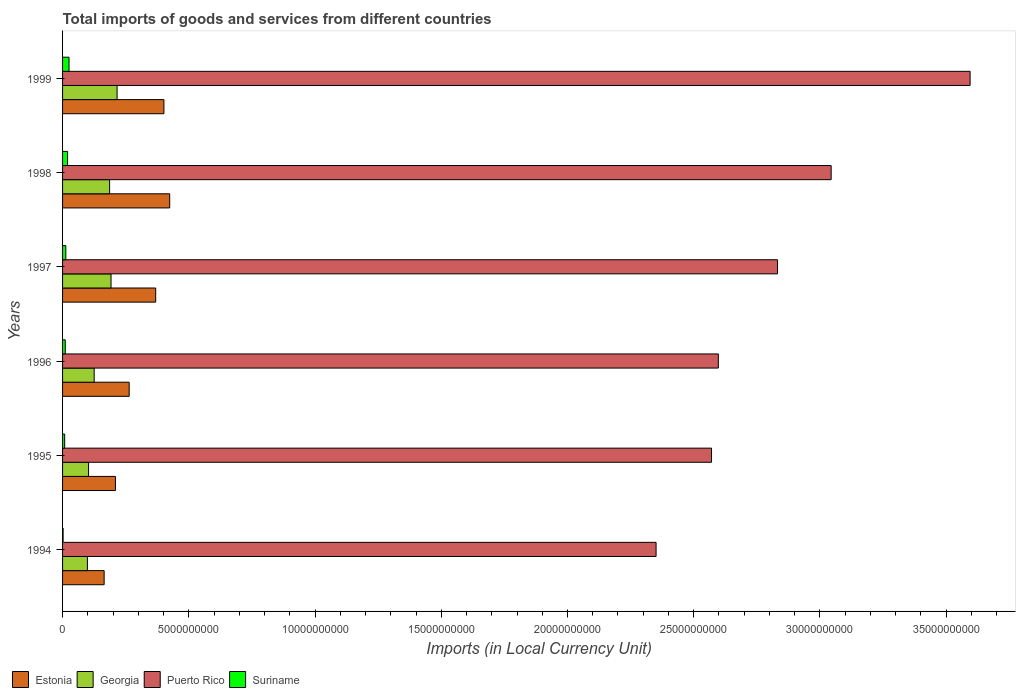Are the number of bars on each tick of the Y-axis equal?
Your answer should be very brief. Yes. How many bars are there on the 4th tick from the top?
Your answer should be very brief. 4. How many bars are there on the 1st tick from the bottom?
Your response must be concise. 4. What is the Amount of goods and services imports in Georgia in 1996?
Your response must be concise. 1.25e+09. Across all years, what is the maximum Amount of goods and services imports in Estonia?
Your answer should be compact. 4.24e+09. Across all years, what is the minimum Amount of goods and services imports in Estonia?
Provide a short and direct response. 1.65e+09. In which year was the Amount of goods and services imports in Puerto Rico maximum?
Provide a short and direct response. 1999. What is the total Amount of goods and services imports in Estonia in the graph?
Provide a short and direct response. 1.83e+1. What is the difference between the Amount of goods and services imports in Suriname in 1994 and that in 1996?
Offer a terse response. -8.47e+07. What is the difference between the Amount of goods and services imports in Georgia in 1995 and the Amount of goods and services imports in Estonia in 1997?
Provide a short and direct response. -2.66e+09. What is the average Amount of goods and services imports in Puerto Rico per year?
Keep it short and to the point. 2.83e+1. In the year 1997, what is the difference between the Amount of goods and services imports in Georgia and Amount of goods and services imports in Puerto Rico?
Your response must be concise. -2.64e+1. In how many years, is the Amount of goods and services imports in Estonia greater than 21000000000 LCU?
Offer a terse response. 0. What is the ratio of the Amount of goods and services imports in Georgia in 1995 to that in 1998?
Give a very brief answer. 0.55. Is the Amount of goods and services imports in Puerto Rico in 1995 less than that in 1996?
Ensure brevity in your answer.  Yes. Is the difference between the Amount of goods and services imports in Georgia in 1994 and 1999 greater than the difference between the Amount of goods and services imports in Puerto Rico in 1994 and 1999?
Your response must be concise. Yes. What is the difference between the highest and the second highest Amount of goods and services imports in Puerto Rico?
Your answer should be compact. 5.50e+09. What is the difference between the highest and the lowest Amount of goods and services imports in Suriname?
Give a very brief answer. 2.35e+08. Is it the case that in every year, the sum of the Amount of goods and services imports in Suriname and Amount of goods and services imports in Estonia is greater than the sum of Amount of goods and services imports in Puerto Rico and Amount of goods and services imports in Georgia?
Your answer should be very brief. No. What does the 4th bar from the top in 1999 represents?
Keep it short and to the point. Estonia. What does the 3rd bar from the bottom in 1997 represents?
Your answer should be compact. Puerto Rico. How many bars are there?
Your response must be concise. 24. Are all the bars in the graph horizontal?
Provide a succinct answer. Yes. Where does the legend appear in the graph?
Provide a succinct answer. Bottom left. What is the title of the graph?
Provide a succinct answer. Total imports of goods and services from different countries. What is the label or title of the X-axis?
Keep it short and to the point. Imports (in Local Currency Unit). What is the label or title of the Y-axis?
Keep it short and to the point. Years. What is the Imports (in Local Currency Unit) in Estonia in 1994?
Offer a very short reply. 1.65e+09. What is the Imports (in Local Currency Unit) of Georgia in 1994?
Your answer should be compact. 9.85e+08. What is the Imports (in Local Currency Unit) in Puerto Rico in 1994?
Offer a terse response. 2.35e+1. What is the Imports (in Local Currency Unit) in Suriname in 1994?
Your answer should be very brief. 2.14e+07. What is the Imports (in Local Currency Unit) in Estonia in 1995?
Your response must be concise. 2.09e+09. What is the Imports (in Local Currency Unit) in Georgia in 1995?
Give a very brief answer. 1.03e+09. What is the Imports (in Local Currency Unit) of Puerto Rico in 1995?
Give a very brief answer. 2.57e+1. What is the Imports (in Local Currency Unit) in Suriname in 1995?
Offer a very short reply. 8.35e+07. What is the Imports (in Local Currency Unit) in Estonia in 1996?
Offer a terse response. 2.64e+09. What is the Imports (in Local Currency Unit) of Georgia in 1996?
Provide a succinct answer. 1.25e+09. What is the Imports (in Local Currency Unit) of Puerto Rico in 1996?
Offer a very short reply. 2.60e+1. What is the Imports (in Local Currency Unit) of Suriname in 1996?
Ensure brevity in your answer.  1.06e+08. What is the Imports (in Local Currency Unit) of Estonia in 1997?
Make the answer very short. 3.69e+09. What is the Imports (in Local Currency Unit) in Georgia in 1997?
Your answer should be very brief. 1.92e+09. What is the Imports (in Local Currency Unit) in Puerto Rico in 1997?
Keep it short and to the point. 2.83e+1. What is the Imports (in Local Currency Unit) in Suriname in 1997?
Provide a succinct answer. 1.29e+08. What is the Imports (in Local Currency Unit) in Estonia in 1998?
Ensure brevity in your answer.  4.24e+09. What is the Imports (in Local Currency Unit) in Georgia in 1998?
Your answer should be compact. 1.86e+09. What is the Imports (in Local Currency Unit) of Puerto Rico in 1998?
Make the answer very short. 3.04e+1. What is the Imports (in Local Currency Unit) in Suriname in 1998?
Make the answer very short. 1.98e+08. What is the Imports (in Local Currency Unit) of Estonia in 1999?
Ensure brevity in your answer.  4.01e+09. What is the Imports (in Local Currency Unit) of Georgia in 1999?
Provide a short and direct response. 2.16e+09. What is the Imports (in Local Currency Unit) in Puerto Rico in 1999?
Give a very brief answer. 3.59e+1. What is the Imports (in Local Currency Unit) of Suriname in 1999?
Provide a short and direct response. 2.56e+08. Across all years, what is the maximum Imports (in Local Currency Unit) in Estonia?
Give a very brief answer. 4.24e+09. Across all years, what is the maximum Imports (in Local Currency Unit) of Georgia?
Your response must be concise. 2.16e+09. Across all years, what is the maximum Imports (in Local Currency Unit) in Puerto Rico?
Your answer should be very brief. 3.59e+1. Across all years, what is the maximum Imports (in Local Currency Unit) of Suriname?
Keep it short and to the point. 2.56e+08. Across all years, what is the minimum Imports (in Local Currency Unit) in Estonia?
Your response must be concise. 1.65e+09. Across all years, what is the minimum Imports (in Local Currency Unit) in Georgia?
Offer a very short reply. 9.85e+08. Across all years, what is the minimum Imports (in Local Currency Unit) of Puerto Rico?
Provide a short and direct response. 2.35e+1. Across all years, what is the minimum Imports (in Local Currency Unit) of Suriname?
Your answer should be compact. 2.14e+07. What is the total Imports (in Local Currency Unit) of Estonia in the graph?
Keep it short and to the point. 1.83e+1. What is the total Imports (in Local Currency Unit) of Georgia in the graph?
Give a very brief answer. 9.21e+09. What is the total Imports (in Local Currency Unit) in Puerto Rico in the graph?
Offer a terse response. 1.70e+11. What is the total Imports (in Local Currency Unit) of Suriname in the graph?
Offer a terse response. 7.95e+08. What is the difference between the Imports (in Local Currency Unit) of Estonia in 1994 and that in 1995?
Make the answer very short. -4.48e+08. What is the difference between the Imports (in Local Currency Unit) in Georgia in 1994 and that in 1995?
Offer a terse response. -4.48e+07. What is the difference between the Imports (in Local Currency Unit) of Puerto Rico in 1994 and that in 1995?
Offer a very short reply. -2.20e+09. What is the difference between the Imports (in Local Currency Unit) in Suriname in 1994 and that in 1995?
Your answer should be very brief. -6.20e+07. What is the difference between the Imports (in Local Currency Unit) of Estonia in 1994 and that in 1996?
Provide a short and direct response. -9.92e+08. What is the difference between the Imports (in Local Currency Unit) in Georgia in 1994 and that in 1996?
Your answer should be compact. -2.68e+08. What is the difference between the Imports (in Local Currency Unit) in Puerto Rico in 1994 and that in 1996?
Your response must be concise. -2.47e+09. What is the difference between the Imports (in Local Currency Unit) in Suriname in 1994 and that in 1996?
Give a very brief answer. -8.47e+07. What is the difference between the Imports (in Local Currency Unit) of Estonia in 1994 and that in 1997?
Your answer should be compact. -2.04e+09. What is the difference between the Imports (in Local Currency Unit) in Georgia in 1994 and that in 1997?
Provide a short and direct response. -9.35e+08. What is the difference between the Imports (in Local Currency Unit) in Puerto Rico in 1994 and that in 1997?
Your answer should be very brief. -4.81e+09. What is the difference between the Imports (in Local Currency Unit) of Suriname in 1994 and that in 1997?
Your answer should be compact. -1.08e+08. What is the difference between the Imports (in Local Currency Unit) of Estonia in 1994 and that in 1998?
Give a very brief answer. -2.60e+09. What is the difference between the Imports (in Local Currency Unit) of Georgia in 1994 and that in 1998?
Give a very brief answer. -8.79e+08. What is the difference between the Imports (in Local Currency Unit) in Puerto Rico in 1994 and that in 1998?
Ensure brevity in your answer.  -6.94e+09. What is the difference between the Imports (in Local Currency Unit) in Suriname in 1994 and that in 1998?
Give a very brief answer. -1.77e+08. What is the difference between the Imports (in Local Currency Unit) of Estonia in 1994 and that in 1999?
Your answer should be compact. -2.37e+09. What is the difference between the Imports (in Local Currency Unit) in Georgia in 1994 and that in 1999?
Provide a short and direct response. -1.17e+09. What is the difference between the Imports (in Local Currency Unit) of Puerto Rico in 1994 and that in 1999?
Ensure brevity in your answer.  -1.24e+1. What is the difference between the Imports (in Local Currency Unit) of Suriname in 1994 and that in 1999?
Offer a very short reply. -2.35e+08. What is the difference between the Imports (in Local Currency Unit) in Estonia in 1995 and that in 1996?
Provide a short and direct response. -5.44e+08. What is the difference between the Imports (in Local Currency Unit) of Georgia in 1995 and that in 1996?
Your answer should be compact. -2.23e+08. What is the difference between the Imports (in Local Currency Unit) in Puerto Rico in 1995 and that in 1996?
Offer a terse response. -2.71e+08. What is the difference between the Imports (in Local Currency Unit) of Suriname in 1995 and that in 1996?
Make the answer very short. -2.27e+07. What is the difference between the Imports (in Local Currency Unit) in Estonia in 1995 and that in 1997?
Provide a succinct answer. -1.59e+09. What is the difference between the Imports (in Local Currency Unit) in Georgia in 1995 and that in 1997?
Give a very brief answer. -8.90e+08. What is the difference between the Imports (in Local Currency Unit) in Puerto Rico in 1995 and that in 1997?
Your answer should be very brief. -2.62e+09. What is the difference between the Imports (in Local Currency Unit) of Suriname in 1995 and that in 1997?
Provide a short and direct response. -4.59e+07. What is the difference between the Imports (in Local Currency Unit) in Estonia in 1995 and that in 1998?
Keep it short and to the point. -2.15e+09. What is the difference between the Imports (in Local Currency Unit) in Georgia in 1995 and that in 1998?
Provide a succinct answer. -8.34e+08. What is the difference between the Imports (in Local Currency Unit) of Puerto Rico in 1995 and that in 1998?
Give a very brief answer. -4.74e+09. What is the difference between the Imports (in Local Currency Unit) in Suriname in 1995 and that in 1998?
Your response must be concise. -1.15e+08. What is the difference between the Imports (in Local Currency Unit) in Estonia in 1995 and that in 1999?
Make the answer very short. -1.92e+09. What is the difference between the Imports (in Local Currency Unit) of Georgia in 1995 and that in 1999?
Provide a short and direct response. -1.13e+09. What is the difference between the Imports (in Local Currency Unit) of Puerto Rico in 1995 and that in 1999?
Provide a succinct answer. -1.02e+1. What is the difference between the Imports (in Local Currency Unit) in Suriname in 1995 and that in 1999?
Provide a short and direct response. -1.73e+08. What is the difference between the Imports (in Local Currency Unit) in Estonia in 1996 and that in 1997?
Offer a very short reply. -1.05e+09. What is the difference between the Imports (in Local Currency Unit) of Georgia in 1996 and that in 1997?
Provide a succinct answer. -6.67e+08. What is the difference between the Imports (in Local Currency Unit) in Puerto Rico in 1996 and that in 1997?
Ensure brevity in your answer.  -2.34e+09. What is the difference between the Imports (in Local Currency Unit) of Suriname in 1996 and that in 1997?
Make the answer very short. -2.32e+07. What is the difference between the Imports (in Local Currency Unit) in Estonia in 1996 and that in 1998?
Provide a succinct answer. -1.61e+09. What is the difference between the Imports (in Local Currency Unit) in Georgia in 1996 and that in 1998?
Your answer should be very brief. -6.11e+08. What is the difference between the Imports (in Local Currency Unit) in Puerto Rico in 1996 and that in 1998?
Make the answer very short. -4.47e+09. What is the difference between the Imports (in Local Currency Unit) in Suriname in 1996 and that in 1998?
Give a very brief answer. -9.22e+07. What is the difference between the Imports (in Local Currency Unit) in Estonia in 1996 and that in 1999?
Offer a terse response. -1.38e+09. What is the difference between the Imports (in Local Currency Unit) of Georgia in 1996 and that in 1999?
Provide a succinct answer. -9.07e+08. What is the difference between the Imports (in Local Currency Unit) of Puerto Rico in 1996 and that in 1999?
Offer a very short reply. -9.97e+09. What is the difference between the Imports (in Local Currency Unit) of Suriname in 1996 and that in 1999?
Make the answer very short. -1.50e+08. What is the difference between the Imports (in Local Currency Unit) in Estonia in 1997 and that in 1998?
Your response must be concise. -5.55e+08. What is the difference between the Imports (in Local Currency Unit) in Georgia in 1997 and that in 1998?
Provide a succinct answer. 5.60e+07. What is the difference between the Imports (in Local Currency Unit) in Puerto Rico in 1997 and that in 1998?
Your answer should be very brief. -2.12e+09. What is the difference between the Imports (in Local Currency Unit) of Suriname in 1997 and that in 1998?
Offer a terse response. -6.90e+07. What is the difference between the Imports (in Local Currency Unit) of Estonia in 1997 and that in 1999?
Provide a succinct answer. -3.26e+08. What is the difference between the Imports (in Local Currency Unit) in Georgia in 1997 and that in 1999?
Give a very brief answer. -2.40e+08. What is the difference between the Imports (in Local Currency Unit) in Puerto Rico in 1997 and that in 1999?
Provide a succinct answer. -7.63e+09. What is the difference between the Imports (in Local Currency Unit) of Suriname in 1997 and that in 1999?
Offer a very short reply. -1.27e+08. What is the difference between the Imports (in Local Currency Unit) of Estonia in 1998 and that in 1999?
Keep it short and to the point. 2.29e+08. What is the difference between the Imports (in Local Currency Unit) of Georgia in 1998 and that in 1999?
Provide a short and direct response. -2.96e+08. What is the difference between the Imports (in Local Currency Unit) of Puerto Rico in 1998 and that in 1999?
Offer a terse response. -5.50e+09. What is the difference between the Imports (in Local Currency Unit) of Suriname in 1998 and that in 1999?
Ensure brevity in your answer.  -5.77e+07. What is the difference between the Imports (in Local Currency Unit) in Estonia in 1994 and the Imports (in Local Currency Unit) in Georgia in 1995?
Your answer should be compact. 6.17e+08. What is the difference between the Imports (in Local Currency Unit) of Estonia in 1994 and the Imports (in Local Currency Unit) of Puerto Rico in 1995?
Make the answer very short. -2.41e+1. What is the difference between the Imports (in Local Currency Unit) in Estonia in 1994 and the Imports (in Local Currency Unit) in Suriname in 1995?
Give a very brief answer. 1.56e+09. What is the difference between the Imports (in Local Currency Unit) of Georgia in 1994 and the Imports (in Local Currency Unit) of Puerto Rico in 1995?
Provide a short and direct response. -2.47e+1. What is the difference between the Imports (in Local Currency Unit) in Georgia in 1994 and the Imports (in Local Currency Unit) in Suriname in 1995?
Keep it short and to the point. 9.01e+08. What is the difference between the Imports (in Local Currency Unit) of Puerto Rico in 1994 and the Imports (in Local Currency Unit) of Suriname in 1995?
Provide a succinct answer. 2.34e+1. What is the difference between the Imports (in Local Currency Unit) in Estonia in 1994 and the Imports (in Local Currency Unit) in Georgia in 1996?
Provide a short and direct response. 3.95e+08. What is the difference between the Imports (in Local Currency Unit) of Estonia in 1994 and the Imports (in Local Currency Unit) of Puerto Rico in 1996?
Offer a very short reply. -2.43e+1. What is the difference between the Imports (in Local Currency Unit) in Estonia in 1994 and the Imports (in Local Currency Unit) in Suriname in 1996?
Provide a short and direct response. 1.54e+09. What is the difference between the Imports (in Local Currency Unit) of Georgia in 1994 and the Imports (in Local Currency Unit) of Puerto Rico in 1996?
Make the answer very short. -2.50e+1. What is the difference between the Imports (in Local Currency Unit) in Georgia in 1994 and the Imports (in Local Currency Unit) in Suriname in 1996?
Offer a very short reply. 8.79e+08. What is the difference between the Imports (in Local Currency Unit) in Puerto Rico in 1994 and the Imports (in Local Currency Unit) in Suriname in 1996?
Ensure brevity in your answer.  2.34e+1. What is the difference between the Imports (in Local Currency Unit) of Estonia in 1994 and the Imports (in Local Currency Unit) of Georgia in 1997?
Provide a succinct answer. -2.73e+08. What is the difference between the Imports (in Local Currency Unit) of Estonia in 1994 and the Imports (in Local Currency Unit) of Puerto Rico in 1997?
Your response must be concise. -2.67e+1. What is the difference between the Imports (in Local Currency Unit) of Estonia in 1994 and the Imports (in Local Currency Unit) of Suriname in 1997?
Your answer should be very brief. 1.52e+09. What is the difference between the Imports (in Local Currency Unit) of Georgia in 1994 and the Imports (in Local Currency Unit) of Puerto Rico in 1997?
Offer a very short reply. -2.73e+1. What is the difference between the Imports (in Local Currency Unit) in Georgia in 1994 and the Imports (in Local Currency Unit) in Suriname in 1997?
Offer a very short reply. 8.55e+08. What is the difference between the Imports (in Local Currency Unit) in Puerto Rico in 1994 and the Imports (in Local Currency Unit) in Suriname in 1997?
Your answer should be compact. 2.34e+1. What is the difference between the Imports (in Local Currency Unit) in Estonia in 1994 and the Imports (in Local Currency Unit) in Georgia in 1998?
Your answer should be very brief. -2.17e+08. What is the difference between the Imports (in Local Currency Unit) of Estonia in 1994 and the Imports (in Local Currency Unit) of Puerto Rico in 1998?
Keep it short and to the point. -2.88e+1. What is the difference between the Imports (in Local Currency Unit) of Estonia in 1994 and the Imports (in Local Currency Unit) of Suriname in 1998?
Your response must be concise. 1.45e+09. What is the difference between the Imports (in Local Currency Unit) of Georgia in 1994 and the Imports (in Local Currency Unit) of Puerto Rico in 1998?
Make the answer very short. -2.95e+1. What is the difference between the Imports (in Local Currency Unit) in Georgia in 1994 and the Imports (in Local Currency Unit) in Suriname in 1998?
Ensure brevity in your answer.  7.86e+08. What is the difference between the Imports (in Local Currency Unit) in Puerto Rico in 1994 and the Imports (in Local Currency Unit) in Suriname in 1998?
Keep it short and to the point. 2.33e+1. What is the difference between the Imports (in Local Currency Unit) in Estonia in 1994 and the Imports (in Local Currency Unit) in Georgia in 1999?
Offer a terse response. -5.13e+08. What is the difference between the Imports (in Local Currency Unit) in Estonia in 1994 and the Imports (in Local Currency Unit) in Puerto Rico in 1999?
Keep it short and to the point. -3.43e+1. What is the difference between the Imports (in Local Currency Unit) of Estonia in 1994 and the Imports (in Local Currency Unit) of Suriname in 1999?
Your answer should be compact. 1.39e+09. What is the difference between the Imports (in Local Currency Unit) of Georgia in 1994 and the Imports (in Local Currency Unit) of Puerto Rico in 1999?
Your response must be concise. -3.50e+1. What is the difference between the Imports (in Local Currency Unit) in Georgia in 1994 and the Imports (in Local Currency Unit) in Suriname in 1999?
Provide a short and direct response. 7.29e+08. What is the difference between the Imports (in Local Currency Unit) in Puerto Rico in 1994 and the Imports (in Local Currency Unit) in Suriname in 1999?
Your response must be concise. 2.33e+1. What is the difference between the Imports (in Local Currency Unit) of Estonia in 1995 and the Imports (in Local Currency Unit) of Georgia in 1996?
Offer a terse response. 8.42e+08. What is the difference between the Imports (in Local Currency Unit) of Estonia in 1995 and the Imports (in Local Currency Unit) of Puerto Rico in 1996?
Provide a short and direct response. -2.39e+1. What is the difference between the Imports (in Local Currency Unit) of Estonia in 1995 and the Imports (in Local Currency Unit) of Suriname in 1996?
Provide a short and direct response. 1.99e+09. What is the difference between the Imports (in Local Currency Unit) in Georgia in 1995 and the Imports (in Local Currency Unit) in Puerto Rico in 1996?
Offer a terse response. -2.49e+1. What is the difference between the Imports (in Local Currency Unit) of Georgia in 1995 and the Imports (in Local Currency Unit) of Suriname in 1996?
Your answer should be compact. 9.23e+08. What is the difference between the Imports (in Local Currency Unit) in Puerto Rico in 1995 and the Imports (in Local Currency Unit) in Suriname in 1996?
Ensure brevity in your answer.  2.56e+1. What is the difference between the Imports (in Local Currency Unit) of Estonia in 1995 and the Imports (in Local Currency Unit) of Georgia in 1997?
Offer a terse response. 1.75e+08. What is the difference between the Imports (in Local Currency Unit) of Estonia in 1995 and the Imports (in Local Currency Unit) of Puerto Rico in 1997?
Ensure brevity in your answer.  -2.62e+1. What is the difference between the Imports (in Local Currency Unit) of Estonia in 1995 and the Imports (in Local Currency Unit) of Suriname in 1997?
Your answer should be very brief. 1.96e+09. What is the difference between the Imports (in Local Currency Unit) of Georgia in 1995 and the Imports (in Local Currency Unit) of Puerto Rico in 1997?
Provide a short and direct response. -2.73e+1. What is the difference between the Imports (in Local Currency Unit) of Georgia in 1995 and the Imports (in Local Currency Unit) of Suriname in 1997?
Provide a succinct answer. 9.00e+08. What is the difference between the Imports (in Local Currency Unit) in Puerto Rico in 1995 and the Imports (in Local Currency Unit) in Suriname in 1997?
Keep it short and to the point. 2.56e+1. What is the difference between the Imports (in Local Currency Unit) of Estonia in 1995 and the Imports (in Local Currency Unit) of Georgia in 1998?
Provide a short and direct response. 2.31e+08. What is the difference between the Imports (in Local Currency Unit) in Estonia in 1995 and the Imports (in Local Currency Unit) in Puerto Rico in 1998?
Provide a short and direct response. -2.83e+1. What is the difference between the Imports (in Local Currency Unit) of Estonia in 1995 and the Imports (in Local Currency Unit) of Suriname in 1998?
Your answer should be very brief. 1.90e+09. What is the difference between the Imports (in Local Currency Unit) of Georgia in 1995 and the Imports (in Local Currency Unit) of Puerto Rico in 1998?
Ensure brevity in your answer.  -2.94e+1. What is the difference between the Imports (in Local Currency Unit) in Georgia in 1995 and the Imports (in Local Currency Unit) in Suriname in 1998?
Ensure brevity in your answer.  8.31e+08. What is the difference between the Imports (in Local Currency Unit) of Puerto Rico in 1995 and the Imports (in Local Currency Unit) of Suriname in 1998?
Give a very brief answer. 2.55e+1. What is the difference between the Imports (in Local Currency Unit) of Estonia in 1995 and the Imports (in Local Currency Unit) of Georgia in 1999?
Your response must be concise. -6.52e+07. What is the difference between the Imports (in Local Currency Unit) of Estonia in 1995 and the Imports (in Local Currency Unit) of Puerto Rico in 1999?
Give a very brief answer. -3.39e+1. What is the difference between the Imports (in Local Currency Unit) of Estonia in 1995 and the Imports (in Local Currency Unit) of Suriname in 1999?
Make the answer very short. 1.84e+09. What is the difference between the Imports (in Local Currency Unit) of Georgia in 1995 and the Imports (in Local Currency Unit) of Puerto Rico in 1999?
Provide a succinct answer. -3.49e+1. What is the difference between the Imports (in Local Currency Unit) in Georgia in 1995 and the Imports (in Local Currency Unit) in Suriname in 1999?
Ensure brevity in your answer.  7.73e+08. What is the difference between the Imports (in Local Currency Unit) in Puerto Rico in 1995 and the Imports (in Local Currency Unit) in Suriname in 1999?
Keep it short and to the point. 2.54e+1. What is the difference between the Imports (in Local Currency Unit) in Estonia in 1996 and the Imports (in Local Currency Unit) in Georgia in 1997?
Your answer should be compact. 7.19e+08. What is the difference between the Imports (in Local Currency Unit) in Estonia in 1996 and the Imports (in Local Currency Unit) in Puerto Rico in 1997?
Make the answer very short. -2.57e+1. What is the difference between the Imports (in Local Currency Unit) in Estonia in 1996 and the Imports (in Local Currency Unit) in Suriname in 1997?
Provide a short and direct response. 2.51e+09. What is the difference between the Imports (in Local Currency Unit) of Georgia in 1996 and the Imports (in Local Currency Unit) of Puerto Rico in 1997?
Make the answer very short. -2.71e+1. What is the difference between the Imports (in Local Currency Unit) of Georgia in 1996 and the Imports (in Local Currency Unit) of Suriname in 1997?
Your answer should be compact. 1.12e+09. What is the difference between the Imports (in Local Currency Unit) in Puerto Rico in 1996 and the Imports (in Local Currency Unit) in Suriname in 1997?
Provide a short and direct response. 2.58e+1. What is the difference between the Imports (in Local Currency Unit) of Estonia in 1996 and the Imports (in Local Currency Unit) of Georgia in 1998?
Ensure brevity in your answer.  7.75e+08. What is the difference between the Imports (in Local Currency Unit) in Estonia in 1996 and the Imports (in Local Currency Unit) in Puerto Rico in 1998?
Give a very brief answer. -2.78e+1. What is the difference between the Imports (in Local Currency Unit) of Estonia in 1996 and the Imports (in Local Currency Unit) of Suriname in 1998?
Offer a very short reply. 2.44e+09. What is the difference between the Imports (in Local Currency Unit) in Georgia in 1996 and the Imports (in Local Currency Unit) in Puerto Rico in 1998?
Provide a succinct answer. -2.92e+1. What is the difference between the Imports (in Local Currency Unit) in Georgia in 1996 and the Imports (in Local Currency Unit) in Suriname in 1998?
Offer a very short reply. 1.05e+09. What is the difference between the Imports (in Local Currency Unit) of Puerto Rico in 1996 and the Imports (in Local Currency Unit) of Suriname in 1998?
Give a very brief answer. 2.58e+1. What is the difference between the Imports (in Local Currency Unit) of Estonia in 1996 and the Imports (in Local Currency Unit) of Georgia in 1999?
Make the answer very short. 4.79e+08. What is the difference between the Imports (in Local Currency Unit) of Estonia in 1996 and the Imports (in Local Currency Unit) of Puerto Rico in 1999?
Offer a terse response. -3.33e+1. What is the difference between the Imports (in Local Currency Unit) in Estonia in 1996 and the Imports (in Local Currency Unit) in Suriname in 1999?
Make the answer very short. 2.38e+09. What is the difference between the Imports (in Local Currency Unit) of Georgia in 1996 and the Imports (in Local Currency Unit) of Puerto Rico in 1999?
Ensure brevity in your answer.  -3.47e+1. What is the difference between the Imports (in Local Currency Unit) of Georgia in 1996 and the Imports (in Local Currency Unit) of Suriname in 1999?
Provide a succinct answer. 9.96e+08. What is the difference between the Imports (in Local Currency Unit) in Puerto Rico in 1996 and the Imports (in Local Currency Unit) in Suriname in 1999?
Your answer should be compact. 2.57e+1. What is the difference between the Imports (in Local Currency Unit) of Estonia in 1997 and the Imports (in Local Currency Unit) of Georgia in 1998?
Keep it short and to the point. 1.83e+09. What is the difference between the Imports (in Local Currency Unit) of Estonia in 1997 and the Imports (in Local Currency Unit) of Puerto Rico in 1998?
Offer a very short reply. -2.68e+1. What is the difference between the Imports (in Local Currency Unit) in Estonia in 1997 and the Imports (in Local Currency Unit) in Suriname in 1998?
Provide a succinct answer. 3.49e+09. What is the difference between the Imports (in Local Currency Unit) in Georgia in 1997 and the Imports (in Local Currency Unit) in Puerto Rico in 1998?
Your answer should be very brief. -2.85e+1. What is the difference between the Imports (in Local Currency Unit) in Georgia in 1997 and the Imports (in Local Currency Unit) in Suriname in 1998?
Provide a short and direct response. 1.72e+09. What is the difference between the Imports (in Local Currency Unit) of Puerto Rico in 1997 and the Imports (in Local Currency Unit) of Suriname in 1998?
Ensure brevity in your answer.  2.81e+1. What is the difference between the Imports (in Local Currency Unit) of Estonia in 1997 and the Imports (in Local Currency Unit) of Georgia in 1999?
Keep it short and to the point. 1.53e+09. What is the difference between the Imports (in Local Currency Unit) of Estonia in 1997 and the Imports (in Local Currency Unit) of Puerto Rico in 1999?
Provide a succinct answer. -3.23e+1. What is the difference between the Imports (in Local Currency Unit) in Estonia in 1997 and the Imports (in Local Currency Unit) in Suriname in 1999?
Offer a very short reply. 3.43e+09. What is the difference between the Imports (in Local Currency Unit) of Georgia in 1997 and the Imports (in Local Currency Unit) of Puerto Rico in 1999?
Your response must be concise. -3.40e+1. What is the difference between the Imports (in Local Currency Unit) of Georgia in 1997 and the Imports (in Local Currency Unit) of Suriname in 1999?
Your answer should be compact. 1.66e+09. What is the difference between the Imports (in Local Currency Unit) in Puerto Rico in 1997 and the Imports (in Local Currency Unit) in Suriname in 1999?
Keep it short and to the point. 2.81e+1. What is the difference between the Imports (in Local Currency Unit) of Estonia in 1998 and the Imports (in Local Currency Unit) of Georgia in 1999?
Keep it short and to the point. 2.08e+09. What is the difference between the Imports (in Local Currency Unit) in Estonia in 1998 and the Imports (in Local Currency Unit) in Puerto Rico in 1999?
Provide a succinct answer. -3.17e+1. What is the difference between the Imports (in Local Currency Unit) of Estonia in 1998 and the Imports (in Local Currency Unit) of Suriname in 1999?
Your answer should be very brief. 3.99e+09. What is the difference between the Imports (in Local Currency Unit) of Georgia in 1998 and the Imports (in Local Currency Unit) of Puerto Rico in 1999?
Keep it short and to the point. -3.41e+1. What is the difference between the Imports (in Local Currency Unit) of Georgia in 1998 and the Imports (in Local Currency Unit) of Suriname in 1999?
Keep it short and to the point. 1.61e+09. What is the difference between the Imports (in Local Currency Unit) in Puerto Rico in 1998 and the Imports (in Local Currency Unit) in Suriname in 1999?
Offer a terse response. 3.02e+1. What is the average Imports (in Local Currency Unit) of Estonia per year?
Your answer should be very brief. 3.05e+09. What is the average Imports (in Local Currency Unit) in Georgia per year?
Your answer should be very brief. 1.53e+09. What is the average Imports (in Local Currency Unit) in Puerto Rico per year?
Ensure brevity in your answer.  2.83e+1. What is the average Imports (in Local Currency Unit) in Suriname per year?
Keep it short and to the point. 1.32e+08. In the year 1994, what is the difference between the Imports (in Local Currency Unit) of Estonia and Imports (in Local Currency Unit) of Georgia?
Your answer should be compact. 6.62e+08. In the year 1994, what is the difference between the Imports (in Local Currency Unit) of Estonia and Imports (in Local Currency Unit) of Puerto Rico?
Provide a succinct answer. -2.19e+1. In the year 1994, what is the difference between the Imports (in Local Currency Unit) of Estonia and Imports (in Local Currency Unit) of Suriname?
Give a very brief answer. 1.63e+09. In the year 1994, what is the difference between the Imports (in Local Currency Unit) in Georgia and Imports (in Local Currency Unit) in Puerto Rico?
Provide a short and direct response. -2.25e+1. In the year 1994, what is the difference between the Imports (in Local Currency Unit) of Georgia and Imports (in Local Currency Unit) of Suriname?
Offer a very short reply. 9.63e+08. In the year 1994, what is the difference between the Imports (in Local Currency Unit) in Puerto Rico and Imports (in Local Currency Unit) in Suriname?
Provide a succinct answer. 2.35e+1. In the year 1995, what is the difference between the Imports (in Local Currency Unit) in Estonia and Imports (in Local Currency Unit) in Georgia?
Keep it short and to the point. 1.06e+09. In the year 1995, what is the difference between the Imports (in Local Currency Unit) of Estonia and Imports (in Local Currency Unit) of Puerto Rico?
Offer a terse response. -2.36e+1. In the year 1995, what is the difference between the Imports (in Local Currency Unit) of Estonia and Imports (in Local Currency Unit) of Suriname?
Your response must be concise. 2.01e+09. In the year 1995, what is the difference between the Imports (in Local Currency Unit) of Georgia and Imports (in Local Currency Unit) of Puerto Rico?
Provide a short and direct response. -2.47e+1. In the year 1995, what is the difference between the Imports (in Local Currency Unit) in Georgia and Imports (in Local Currency Unit) in Suriname?
Give a very brief answer. 9.46e+08. In the year 1995, what is the difference between the Imports (in Local Currency Unit) of Puerto Rico and Imports (in Local Currency Unit) of Suriname?
Provide a short and direct response. 2.56e+1. In the year 1996, what is the difference between the Imports (in Local Currency Unit) of Estonia and Imports (in Local Currency Unit) of Georgia?
Your response must be concise. 1.39e+09. In the year 1996, what is the difference between the Imports (in Local Currency Unit) of Estonia and Imports (in Local Currency Unit) of Puerto Rico?
Your response must be concise. -2.33e+1. In the year 1996, what is the difference between the Imports (in Local Currency Unit) in Estonia and Imports (in Local Currency Unit) in Suriname?
Offer a terse response. 2.53e+09. In the year 1996, what is the difference between the Imports (in Local Currency Unit) in Georgia and Imports (in Local Currency Unit) in Puerto Rico?
Provide a short and direct response. -2.47e+1. In the year 1996, what is the difference between the Imports (in Local Currency Unit) in Georgia and Imports (in Local Currency Unit) in Suriname?
Make the answer very short. 1.15e+09. In the year 1996, what is the difference between the Imports (in Local Currency Unit) of Puerto Rico and Imports (in Local Currency Unit) of Suriname?
Offer a very short reply. 2.59e+1. In the year 1997, what is the difference between the Imports (in Local Currency Unit) in Estonia and Imports (in Local Currency Unit) in Georgia?
Your answer should be compact. 1.77e+09. In the year 1997, what is the difference between the Imports (in Local Currency Unit) of Estonia and Imports (in Local Currency Unit) of Puerto Rico?
Offer a terse response. -2.46e+1. In the year 1997, what is the difference between the Imports (in Local Currency Unit) of Estonia and Imports (in Local Currency Unit) of Suriname?
Provide a short and direct response. 3.56e+09. In the year 1997, what is the difference between the Imports (in Local Currency Unit) in Georgia and Imports (in Local Currency Unit) in Puerto Rico?
Make the answer very short. -2.64e+1. In the year 1997, what is the difference between the Imports (in Local Currency Unit) of Georgia and Imports (in Local Currency Unit) of Suriname?
Provide a succinct answer. 1.79e+09. In the year 1997, what is the difference between the Imports (in Local Currency Unit) of Puerto Rico and Imports (in Local Currency Unit) of Suriname?
Give a very brief answer. 2.82e+1. In the year 1998, what is the difference between the Imports (in Local Currency Unit) in Estonia and Imports (in Local Currency Unit) in Georgia?
Your answer should be compact. 2.38e+09. In the year 1998, what is the difference between the Imports (in Local Currency Unit) of Estonia and Imports (in Local Currency Unit) of Puerto Rico?
Ensure brevity in your answer.  -2.62e+1. In the year 1998, what is the difference between the Imports (in Local Currency Unit) in Estonia and Imports (in Local Currency Unit) in Suriname?
Give a very brief answer. 4.05e+09. In the year 1998, what is the difference between the Imports (in Local Currency Unit) in Georgia and Imports (in Local Currency Unit) in Puerto Rico?
Give a very brief answer. -2.86e+1. In the year 1998, what is the difference between the Imports (in Local Currency Unit) in Georgia and Imports (in Local Currency Unit) in Suriname?
Make the answer very short. 1.67e+09. In the year 1998, what is the difference between the Imports (in Local Currency Unit) of Puerto Rico and Imports (in Local Currency Unit) of Suriname?
Your answer should be very brief. 3.02e+1. In the year 1999, what is the difference between the Imports (in Local Currency Unit) in Estonia and Imports (in Local Currency Unit) in Georgia?
Provide a succinct answer. 1.86e+09. In the year 1999, what is the difference between the Imports (in Local Currency Unit) in Estonia and Imports (in Local Currency Unit) in Puerto Rico?
Offer a terse response. -3.19e+1. In the year 1999, what is the difference between the Imports (in Local Currency Unit) in Estonia and Imports (in Local Currency Unit) in Suriname?
Ensure brevity in your answer.  3.76e+09. In the year 1999, what is the difference between the Imports (in Local Currency Unit) in Georgia and Imports (in Local Currency Unit) in Puerto Rico?
Provide a succinct answer. -3.38e+1. In the year 1999, what is the difference between the Imports (in Local Currency Unit) in Georgia and Imports (in Local Currency Unit) in Suriname?
Provide a short and direct response. 1.90e+09. In the year 1999, what is the difference between the Imports (in Local Currency Unit) in Puerto Rico and Imports (in Local Currency Unit) in Suriname?
Your answer should be compact. 3.57e+1. What is the ratio of the Imports (in Local Currency Unit) in Estonia in 1994 to that in 1995?
Give a very brief answer. 0.79. What is the ratio of the Imports (in Local Currency Unit) in Georgia in 1994 to that in 1995?
Give a very brief answer. 0.96. What is the ratio of the Imports (in Local Currency Unit) of Puerto Rico in 1994 to that in 1995?
Keep it short and to the point. 0.91. What is the ratio of the Imports (in Local Currency Unit) of Suriname in 1994 to that in 1995?
Your response must be concise. 0.26. What is the ratio of the Imports (in Local Currency Unit) of Estonia in 1994 to that in 1996?
Your answer should be very brief. 0.62. What is the ratio of the Imports (in Local Currency Unit) of Georgia in 1994 to that in 1996?
Provide a short and direct response. 0.79. What is the ratio of the Imports (in Local Currency Unit) of Puerto Rico in 1994 to that in 1996?
Provide a succinct answer. 0.91. What is the ratio of the Imports (in Local Currency Unit) of Suriname in 1994 to that in 1996?
Your response must be concise. 0.2. What is the ratio of the Imports (in Local Currency Unit) in Estonia in 1994 to that in 1997?
Give a very brief answer. 0.45. What is the ratio of the Imports (in Local Currency Unit) of Georgia in 1994 to that in 1997?
Keep it short and to the point. 0.51. What is the ratio of the Imports (in Local Currency Unit) in Puerto Rico in 1994 to that in 1997?
Your answer should be very brief. 0.83. What is the ratio of the Imports (in Local Currency Unit) of Suriname in 1994 to that in 1997?
Your response must be concise. 0.17. What is the ratio of the Imports (in Local Currency Unit) of Estonia in 1994 to that in 1998?
Provide a succinct answer. 0.39. What is the ratio of the Imports (in Local Currency Unit) of Georgia in 1994 to that in 1998?
Provide a short and direct response. 0.53. What is the ratio of the Imports (in Local Currency Unit) of Puerto Rico in 1994 to that in 1998?
Provide a short and direct response. 0.77. What is the ratio of the Imports (in Local Currency Unit) in Suriname in 1994 to that in 1998?
Keep it short and to the point. 0.11. What is the ratio of the Imports (in Local Currency Unit) in Estonia in 1994 to that in 1999?
Offer a terse response. 0.41. What is the ratio of the Imports (in Local Currency Unit) of Georgia in 1994 to that in 1999?
Ensure brevity in your answer.  0.46. What is the ratio of the Imports (in Local Currency Unit) of Puerto Rico in 1994 to that in 1999?
Give a very brief answer. 0.65. What is the ratio of the Imports (in Local Currency Unit) of Suriname in 1994 to that in 1999?
Your answer should be compact. 0.08. What is the ratio of the Imports (in Local Currency Unit) in Estonia in 1995 to that in 1996?
Provide a succinct answer. 0.79. What is the ratio of the Imports (in Local Currency Unit) of Georgia in 1995 to that in 1996?
Make the answer very short. 0.82. What is the ratio of the Imports (in Local Currency Unit) of Suriname in 1995 to that in 1996?
Keep it short and to the point. 0.79. What is the ratio of the Imports (in Local Currency Unit) of Estonia in 1995 to that in 1997?
Provide a succinct answer. 0.57. What is the ratio of the Imports (in Local Currency Unit) in Georgia in 1995 to that in 1997?
Your response must be concise. 0.54. What is the ratio of the Imports (in Local Currency Unit) in Puerto Rico in 1995 to that in 1997?
Your response must be concise. 0.91. What is the ratio of the Imports (in Local Currency Unit) of Suriname in 1995 to that in 1997?
Your response must be concise. 0.65. What is the ratio of the Imports (in Local Currency Unit) in Estonia in 1995 to that in 1998?
Give a very brief answer. 0.49. What is the ratio of the Imports (in Local Currency Unit) in Georgia in 1995 to that in 1998?
Offer a very short reply. 0.55. What is the ratio of the Imports (in Local Currency Unit) in Puerto Rico in 1995 to that in 1998?
Give a very brief answer. 0.84. What is the ratio of the Imports (in Local Currency Unit) of Suriname in 1995 to that in 1998?
Your answer should be compact. 0.42. What is the ratio of the Imports (in Local Currency Unit) in Estonia in 1995 to that in 1999?
Provide a short and direct response. 0.52. What is the ratio of the Imports (in Local Currency Unit) in Georgia in 1995 to that in 1999?
Offer a terse response. 0.48. What is the ratio of the Imports (in Local Currency Unit) in Puerto Rico in 1995 to that in 1999?
Keep it short and to the point. 0.72. What is the ratio of the Imports (in Local Currency Unit) in Suriname in 1995 to that in 1999?
Make the answer very short. 0.33. What is the ratio of the Imports (in Local Currency Unit) of Estonia in 1996 to that in 1997?
Provide a succinct answer. 0.72. What is the ratio of the Imports (in Local Currency Unit) in Georgia in 1996 to that in 1997?
Your answer should be very brief. 0.65. What is the ratio of the Imports (in Local Currency Unit) of Puerto Rico in 1996 to that in 1997?
Provide a short and direct response. 0.92. What is the ratio of the Imports (in Local Currency Unit) in Suriname in 1996 to that in 1997?
Make the answer very short. 0.82. What is the ratio of the Imports (in Local Currency Unit) in Estonia in 1996 to that in 1998?
Provide a short and direct response. 0.62. What is the ratio of the Imports (in Local Currency Unit) of Georgia in 1996 to that in 1998?
Provide a succinct answer. 0.67. What is the ratio of the Imports (in Local Currency Unit) of Puerto Rico in 1996 to that in 1998?
Your answer should be compact. 0.85. What is the ratio of the Imports (in Local Currency Unit) in Suriname in 1996 to that in 1998?
Ensure brevity in your answer.  0.54. What is the ratio of the Imports (in Local Currency Unit) in Estonia in 1996 to that in 1999?
Provide a succinct answer. 0.66. What is the ratio of the Imports (in Local Currency Unit) of Georgia in 1996 to that in 1999?
Your answer should be very brief. 0.58. What is the ratio of the Imports (in Local Currency Unit) in Puerto Rico in 1996 to that in 1999?
Provide a succinct answer. 0.72. What is the ratio of the Imports (in Local Currency Unit) of Suriname in 1996 to that in 1999?
Provide a succinct answer. 0.41. What is the ratio of the Imports (in Local Currency Unit) in Estonia in 1997 to that in 1998?
Your response must be concise. 0.87. What is the ratio of the Imports (in Local Currency Unit) in Puerto Rico in 1997 to that in 1998?
Your response must be concise. 0.93. What is the ratio of the Imports (in Local Currency Unit) in Suriname in 1997 to that in 1998?
Keep it short and to the point. 0.65. What is the ratio of the Imports (in Local Currency Unit) of Estonia in 1997 to that in 1999?
Provide a short and direct response. 0.92. What is the ratio of the Imports (in Local Currency Unit) of Georgia in 1997 to that in 1999?
Keep it short and to the point. 0.89. What is the ratio of the Imports (in Local Currency Unit) in Puerto Rico in 1997 to that in 1999?
Offer a terse response. 0.79. What is the ratio of the Imports (in Local Currency Unit) in Suriname in 1997 to that in 1999?
Provide a succinct answer. 0.51. What is the ratio of the Imports (in Local Currency Unit) of Estonia in 1998 to that in 1999?
Your answer should be very brief. 1.06. What is the ratio of the Imports (in Local Currency Unit) of Georgia in 1998 to that in 1999?
Your response must be concise. 0.86. What is the ratio of the Imports (in Local Currency Unit) in Puerto Rico in 1998 to that in 1999?
Your answer should be compact. 0.85. What is the ratio of the Imports (in Local Currency Unit) of Suriname in 1998 to that in 1999?
Provide a short and direct response. 0.77. What is the difference between the highest and the second highest Imports (in Local Currency Unit) in Estonia?
Offer a very short reply. 2.29e+08. What is the difference between the highest and the second highest Imports (in Local Currency Unit) of Georgia?
Ensure brevity in your answer.  2.40e+08. What is the difference between the highest and the second highest Imports (in Local Currency Unit) in Puerto Rico?
Your response must be concise. 5.50e+09. What is the difference between the highest and the second highest Imports (in Local Currency Unit) in Suriname?
Keep it short and to the point. 5.77e+07. What is the difference between the highest and the lowest Imports (in Local Currency Unit) of Estonia?
Give a very brief answer. 2.60e+09. What is the difference between the highest and the lowest Imports (in Local Currency Unit) in Georgia?
Ensure brevity in your answer.  1.17e+09. What is the difference between the highest and the lowest Imports (in Local Currency Unit) of Puerto Rico?
Give a very brief answer. 1.24e+1. What is the difference between the highest and the lowest Imports (in Local Currency Unit) in Suriname?
Provide a succinct answer. 2.35e+08. 